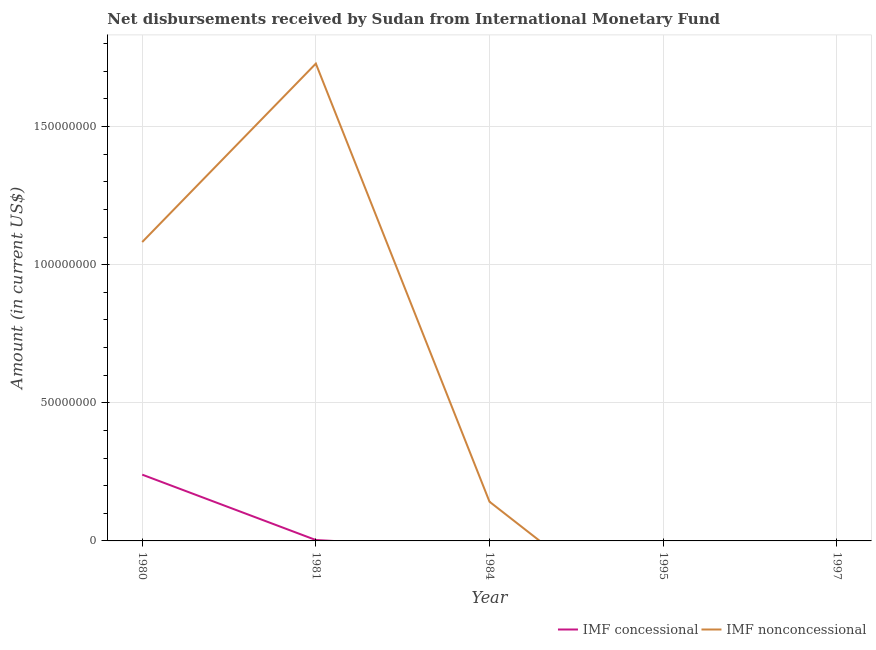How many different coloured lines are there?
Offer a very short reply. 2. Does the line corresponding to net non concessional disbursements from imf intersect with the line corresponding to net concessional disbursements from imf?
Give a very brief answer. Yes. What is the net concessional disbursements from imf in 1981?
Ensure brevity in your answer.  3.20e+05. Across all years, what is the maximum net non concessional disbursements from imf?
Your response must be concise. 1.73e+08. What is the total net concessional disbursements from imf in the graph?
Provide a short and direct response. 2.43e+07. What is the difference between the net concessional disbursements from imf in 1980 and that in 1981?
Provide a succinct answer. 2.37e+07. What is the difference between the net concessional disbursements from imf in 1981 and the net non concessional disbursements from imf in 1995?
Ensure brevity in your answer.  3.20e+05. What is the average net concessional disbursements from imf per year?
Give a very brief answer. 4.86e+06. In the year 1981, what is the difference between the net concessional disbursements from imf and net non concessional disbursements from imf?
Provide a short and direct response. -1.72e+08. In how many years, is the net concessional disbursements from imf greater than 160000000 US$?
Your answer should be very brief. 0. Is the net concessional disbursements from imf in 1980 less than that in 1981?
Provide a short and direct response. No. Is the difference between the net concessional disbursements from imf in 1980 and 1981 greater than the difference between the net non concessional disbursements from imf in 1980 and 1981?
Offer a terse response. Yes. What is the difference between the highest and the second highest net non concessional disbursements from imf?
Offer a very short reply. 6.46e+07. What is the difference between the highest and the lowest net concessional disbursements from imf?
Keep it short and to the point. 2.40e+07. Does the net concessional disbursements from imf monotonically increase over the years?
Make the answer very short. No. Is the net concessional disbursements from imf strictly greater than the net non concessional disbursements from imf over the years?
Keep it short and to the point. No. How many lines are there?
Ensure brevity in your answer.  2. What is the title of the graph?
Make the answer very short. Net disbursements received by Sudan from International Monetary Fund. What is the label or title of the X-axis?
Make the answer very short. Year. What is the label or title of the Y-axis?
Provide a succinct answer. Amount (in current US$). What is the Amount (in current US$) of IMF concessional in 1980?
Provide a succinct answer. 2.40e+07. What is the Amount (in current US$) in IMF nonconcessional in 1980?
Your response must be concise. 1.08e+08. What is the Amount (in current US$) in IMF nonconcessional in 1981?
Your answer should be compact. 1.73e+08. What is the Amount (in current US$) of IMF concessional in 1984?
Your response must be concise. 0. What is the Amount (in current US$) of IMF nonconcessional in 1984?
Make the answer very short. 1.42e+07. What is the Amount (in current US$) of IMF concessional in 1995?
Offer a terse response. 0. What is the Amount (in current US$) in IMF concessional in 1997?
Ensure brevity in your answer.  0. Across all years, what is the maximum Amount (in current US$) in IMF concessional?
Offer a very short reply. 2.40e+07. Across all years, what is the maximum Amount (in current US$) of IMF nonconcessional?
Provide a succinct answer. 1.73e+08. What is the total Amount (in current US$) of IMF concessional in the graph?
Provide a succinct answer. 2.43e+07. What is the total Amount (in current US$) of IMF nonconcessional in the graph?
Keep it short and to the point. 2.95e+08. What is the difference between the Amount (in current US$) in IMF concessional in 1980 and that in 1981?
Make the answer very short. 2.37e+07. What is the difference between the Amount (in current US$) in IMF nonconcessional in 1980 and that in 1981?
Provide a short and direct response. -6.46e+07. What is the difference between the Amount (in current US$) in IMF nonconcessional in 1980 and that in 1984?
Your response must be concise. 9.40e+07. What is the difference between the Amount (in current US$) in IMF nonconcessional in 1981 and that in 1984?
Offer a very short reply. 1.59e+08. What is the difference between the Amount (in current US$) in IMF concessional in 1980 and the Amount (in current US$) in IMF nonconcessional in 1981?
Make the answer very short. -1.49e+08. What is the difference between the Amount (in current US$) in IMF concessional in 1980 and the Amount (in current US$) in IMF nonconcessional in 1984?
Provide a short and direct response. 9.79e+06. What is the difference between the Amount (in current US$) of IMF concessional in 1981 and the Amount (in current US$) of IMF nonconcessional in 1984?
Provide a succinct answer. -1.39e+07. What is the average Amount (in current US$) in IMF concessional per year?
Ensure brevity in your answer.  4.86e+06. What is the average Amount (in current US$) of IMF nonconcessional per year?
Ensure brevity in your answer.  5.90e+07. In the year 1980, what is the difference between the Amount (in current US$) in IMF concessional and Amount (in current US$) in IMF nonconcessional?
Your answer should be very brief. -8.42e+07. In the year 1981, what is the difference between the Amount (in current US$) of IMF concessional and Amount (in current US$) of IMF nonconcessional?
Make the answer very short. -1.72e+08. What is the ratio of the Amount (in current US$) of IMF concessional in 1980 to that in 1981?
Give a very brief answer. 74.97. What is the ratio of the Amount (in current US$) of IMF nonconcessional in 1980 to that in 1981?
Keep it short and to the point. 0.63. What is the ratio of the Amount (in current US$) of IMF nonconcessional in 1980 to that in 1984?
Keep it short and to the point. 7.62. What is the ratio of the Amount (in current US$) in IMF nonconcessional in 1981 to that in 1984?
Keep it short and to the point. 12.17. What is the difference between the highest and the second highest Amount (in current US$) of IMF nonconcessional?
Your response must be concise. 6.46e+07. What is the difference between the highest and the lowest Amount (in current US$) of IMF concessional?
Provide a short and direct response. 2.40e+07. What is the difference between the highest and the lowest Amount (in current US$) of IMF nonconcessional?
Your answer should be compact. 1.73e+08. 